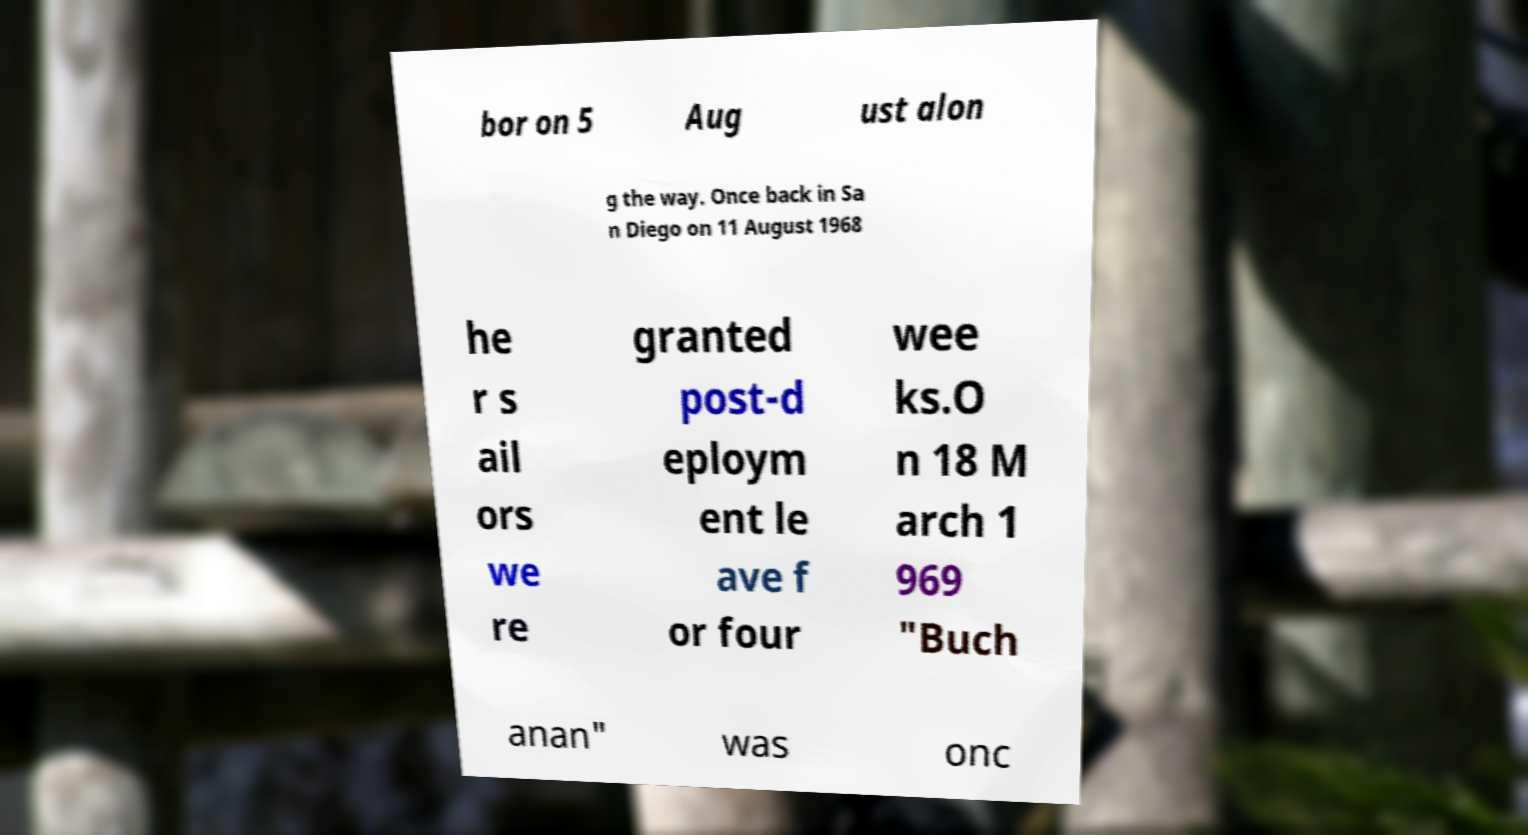Can you accurately transcribe the text from the provided image for me? bor on 5 Aug ust alon g the way. Once back in Sa n Diego on 11 August 1968 he r s ail ors we re granted post-d eploym ent le ave f or four wee ks.O n 18 M arch 1 969 "Buch anan" was onc 